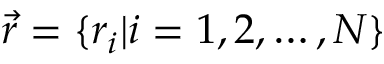<formula> <loc_0><loc_0><loc_500><loc_500>\ V e c { r } = \{ r _ { i } | i = 1 , 2 , \dots , N \}</formula> 